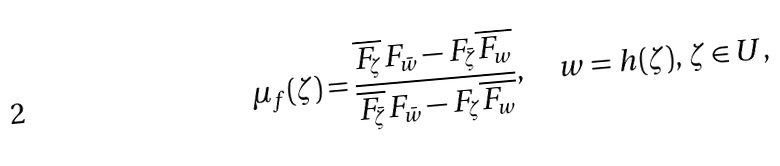Convert formula to latex. <formula><loc_0><loc_0><loc_500><loc_500>\mu _ { f } ( \zeta ) = \frac { \overline { F _ { \zeta } } F _ { \bar { w } } - F _ { \bar { \zeta } } \overline { F _ { w } } } { \overline { F _ { \bar { \zeta } } } F _ { \bar { w } } - F _ { \zeta } \overline { F _ { w } } } , \quad w = h ( \zeta ) , \, \zeta \in U ,</formula> 